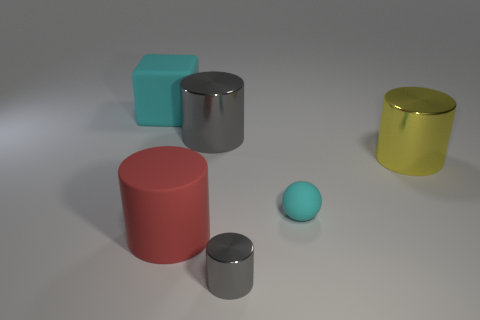How many objects are either tiny cyan rubber balls or big cylinders?
Your response must be concise. 4. The yellow object is what shape?
Provide a short and direct response. Cylinder. What is the size of the red thing that is the same shape as the yellow object?
Provide a short and direct response. Large. There is a cyan rubber object that is left of the cyan thing to the right of the cyan rubber cube; what is its size?
Your answer should be very brief. Large. Are there the same number of big yellow shiny things that are behind the tiny cylinder and small shiny cylinders?
Offer a very short reply. Yes. How many other objects are the same color as the cube?
Provide a short and direct response. 1. Are there fewer metal things behind the red rubber thing than purple shiny cylinders?
Your answer should be compact. No. Are there any metallic cylinders that have the same size as the ball?
Ensure brevity in your answer.  Yes. Is the color of the small metallic object the same as the big metal cylinder that is to the left of the tiny matte thing?
Your response must be concise. Yes. What number of metal objects are on the left side of the metal object that is right of the small shiny thing?
Make the answer very short. 2. 